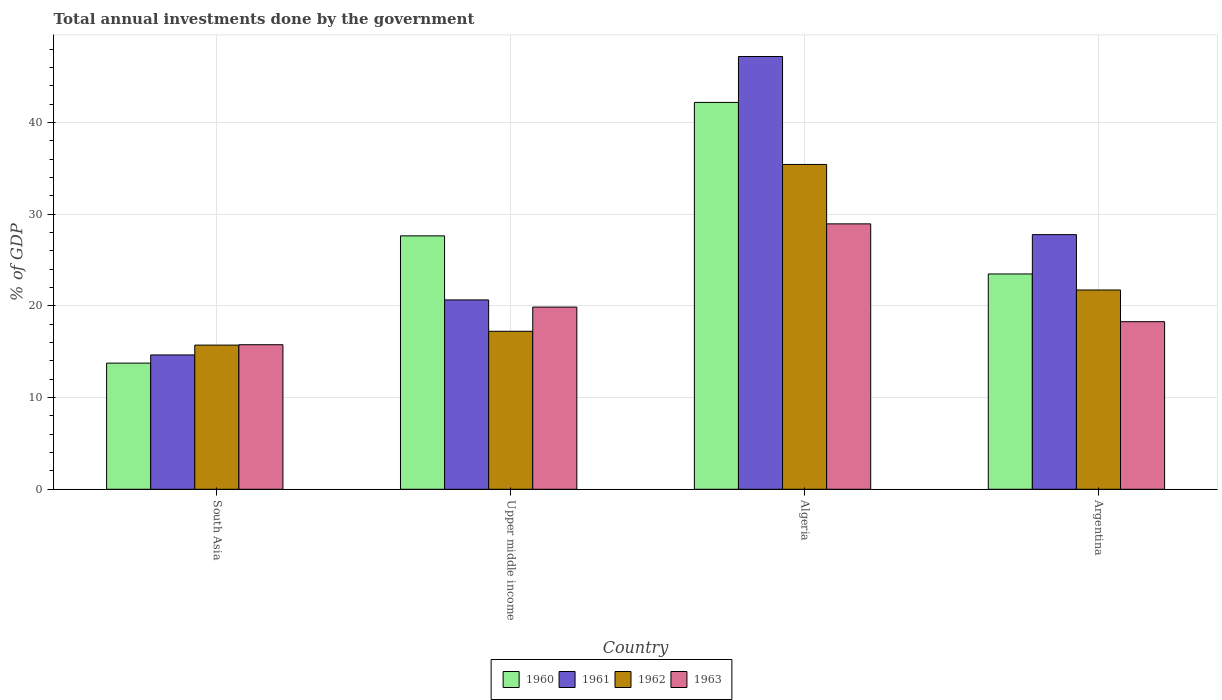Are the number of bars per tick equal to the number of legend labels?
Your answer should be very brief. Yes. Are the number of bars on each tick of the X-axis equal?
Keep it short and to the point. Yes. How many bars are there on the 1st tick from the right?
Offer a very short reply. 4. In how many cases, is the number of bars for a given country not equal to the number of legend labels?
Provide a succinct answer. 0. What is the total annual investments done by the government in 1963 in Upper middle income?
Keep it short and to the point. 19.87. Across all countries, what is the maximum total annual investments done by the government in 1960?
Give a very brief answer. 42.18. Across all countries, what is the minimum total annual investments done by the government in 1962?
Your response must be concise. 15.72. In which country was the total annual investments done by the government in 1961 maximum?
Your answer should be compact. Algeria. In which country was the total annual investments done by the government in 1961 minimum?
Provide a succinct answer. South Asia. What is the total total annual investments done by the government in 1962 in the graph?
Your answer should be compact. 90.1. What is the difference between the total annual investments done by the government in 1960 in South Asia and that in Upper middle income?
Your response must be concise. -13.88. What is the difference between the total annual investments done by the government in 1960 in South Asia and the total annual investments done by the government in 1963 in Argentina?
Provide a short and direct response. -4.52. What is the average total annual investments done by the government in 1961 per country?
Make the answer very short. 27.56. What is the difference between the total annual investments done by the government of/in 1963 and total annual investments done by the government of/in 1961 in South Asia?
Keep it short and to the point. 1.11. In how many countries, is the total annual investments done by the government in 1962 greater than 30 %?
Give a very brief answer. 1. What is the ratio of the total annual investments done by the government in 1963 in Algeria to that in Upper middle income?
Provide a short and direct response. 1.46. Is the difference between the total annual investments done by the government in 1963 in Algeria and South Asia greater than the difference between the total annual investments done by the government in 1961 in Algeria and South Asia?
Give a very brief answer. No. What is the difference between the highest and the second highest total annual investments done by the government in 1962?
Your response must be concise. -18.19. What is the difference between the highest and the lowest total annual investments done by the government in 1960?
Ensure brevity in your answer.  28.43. In how many countries, is the total annual investments done by the government in 1962 greater than the average total annual investments done by the government in 1962 taken over all countries?
Keep it short and to the point. 1. Is the sum of the total annual investments done by the government in 1963 in Argentina and Upper middle income greater than the maximum total annual investments done by the government in 1960 across all countries?
Offer a very short reply. No. How many bars are there?
Your answer should be very brief. 16. What is the difference between two consecutive major ticks on the Y-axis?
Provide a short and direct response. 10. Does the graph contain grids?
Your answer should be compact. Yes. Where does the legend appear in the graph?
Ensure brevity in your answer.  Bottom center. How are the legend labels stacked?
Ensure brevity in your answer.  Horizontal. What is the title of the graph?
Provide a succinct answer. Total annual investments done by the government. What is the label or title of the X-axis?
Ensure brevity in your answer.  Country. What is the label or title of the Y-axis?
Give a very brief answer. % of GDP. What is the % of GDP in 1960 in South Asia?
Your answer should be compact. 13.76. What is the % of GDP in 1961 in South Asia?
Offer a terse response. 14.65. What is the % of GDP of 1962 in South Asia?
Give a very brief answer. 15.72. What is the % of GDP of 1963 in South Asia?
Provide a succinct answer. 15.76. What is the % of GDP of 1960 in Upper middle income?
Ensure brevity in your answer.  27.63. What is the % of GDP in 1961 in Upper middle income?
Your answer should be very brief. 20.65. What is the % of GDP in 1962 in Upper middle income?
Your response must be concise. 17.23. What is the % of GDP in 1963 in Upper middle income?
Keep it short and to the point. 19.87. What is the % of GDP of 1960 in Algeria?
Provide a short and direct response. 42.18. What is the % of GDP of 1961 in Algeria?
Your response must be concise. 47.19. What is the % of GDP of 1962 in Algeria?
Offer a very short reply. 35.42. What is the % of GDP in 1963 in Algeria?
Offer a very short reply. 28.94. What is the % of GDP of 1960 in Argentina?
Your response must be concise. 23.48. What is the % of GDP in 1961 in Argentina?
Offer a very short reply. 27.77. What is the % of GDP in 1962 in Argentina?
Your response must be concise. 21.73. What is the % of GDP of 1963 in Argentina?
Provide a short and direct response. 18.27. Across all countries, what is the maximum % of GDP of 1960?
Provide a succinct answer. 42.18. Across all countries, what is the maximum % of GDP in 1961?
Offer a terse response. 47.19. Across all countries, what is the maximum % of GDP of 1962?
Offer a very short reply. 35.42. Across all countries, what is the maximum % of GDP in 1963?
Provide a short and direct response. 28.94. Across all countries, what is the minimum % of GDP in 1960?
Your answer should be compact. 13.76. Across all countries, what is the minimum % of GDP of 1961?
Ensure brevity in your answer.  14.65. Across all countries, what is the minimum % of GDP in 1962?
Your response must be concise. 15.72. Across all countries, what is the minimum % of GDP of 1963?
Keep it short and to the point. 15.76. What is the total % of GDP of 1960 in the graph?
Offer a terse response. 107.05. What is the total % of GDP in 1961 in the graph?
Provide a short and direct response. 110.25. What is the total % of GDP in 1962 in the graph?
Make the answer very short. 90.1. What is the total % of GDP of 1963 in the graph?
Your response must be concise. 82.84. What is the difference between the % of GDP in 1960 in South Asia and that in Upper middle income?
Keep it short and to the point. -13.88. What is the difference between the % of GDP of 1961 in South Asia and that in Upper middle income?
Keep it short and to the point. -6. What is the difference between the % of GDP of 1962 in South Asia and that in Upper middle income?
Offer a terse response. -1.51. What is the difference between the % of GDP of 1963 in South Asia and that in Upper middle income?
Offer a very short reply. -4.1. What is the difference between the % of GDP in 1960 in South Asia and that in Algeria?
Offer a terse response. -28.43. What is the difference between the % of GDP of 1961 in South Asia and that in Algeria?
Offer a terse response. -32.54. What is the difference between the % of GDP of 1962 in South Asia and that in Algeria?
Offer a terse response. -19.7. What is the difference between the % of GDP of 1963 in South Asia and that in Algeria?
Keep it short and to the point. -13.18. What is the difference between the % of GDP of 1960 in South Asia and that in Argentina?
Give a very brief answer. -9.72. What is the difference between the % of GDP of 1961 in South Asia and that in Argentina?
Provide a succinct answer. -13.12. What is the difference between the % of GDP in 1962 in South Asia and that in Argentina?
Provide a short and direct response. -6.01. What is the difference between the % of GDP in 1963 in South Asia and that in Argentina?
Ensure brevity in your answer.  -2.51. What is the difference between the % of GDP of 1960 in Upper middle income and that in Algeria?
Your answer should be compact. -14.55. What is the difference between the % of GDP of 1961 in Upper middle income and that in Algeria?
Give a very brief answer. -26.54. What is the difference between the % of GDP in 1962 in Upper middle income and that in Algeria?
Your answer should be very brief. -18.19. What is the difference between the % of GDP in 1963 in Upper middle income and that in Algeria?
Your response must be concise. -9.07. What is the difference between the % of GDP in 1960 in Upper middle income and that in Argentina?
Offer a very short reply. 4.15. What is the difference between the % of GDP of 1961 in Upper middle income and that in Argentina?
Offer a terse response. -7.12. What is the difference between the % of GDP of 1962 in Upper middle income and that in Argentina?
Your response must be concise. -4.5. What is the difference between the % of GDP of 1963 in Upper middle income and that in Argentina?
Provide a short and direct response. 1.59. What is the difference between the % of GDP in 1960 in Algeria and that in Argentina?
Provide a succinct answer. 18.71. What is the difference between the % of GDP of 1961 in Algeria and that in Argentina?
Make the answer very short. 19.42. What is the difference between the % of GDP of 1962 in Algeria and that in Argentina?
Your response must be concise. 13.69. What is the difference between the % of GDP in 1963 in Algeria and that in Argentina?
Keep it short and to the point. 10.67. What is the difference between the % of GDP in 1960 in South Asia and the % of GDP in 1961 in Upper middle income?
Offer a terse response. -6.89. What is the difference between the % of GDP of 1960 in South Asia and the % of GDP of 1962 in Upper middle income?
Make the answer very short. -3.47. What is the difference between the % of GDP of 1960 in South Asia and the % of GDP of 1963 in Upper middle income?
Keep it short and to the point. -6.11. What is the difference between the % of GDP in 1961 in South Asia and the % of GDP in 1962 in Upper middle income?
Offer a terse response. -2.58. What is the difference between the % of GDP in 1961 in South Asia and the % of GDP in 1963 in Upper middle income?
Make the answer very short. -5.22. What is the difference between the % of GDP in 1962 in South Asia and the % of GDP in 1963 in Upper middle income?
Your answer should be very brief. -4.15. What is the difference between the % of GDP in 1960 in South Asia and the % of GDP in 1961 in Algeria?
Give a very brief answer. -33.43. What is the difference between the % of GDP in 1960 in South Asia and the % of GDP in 1962 in Algeria?
Offer a terse response. -21.66. What is the difference between the % of GDP in 1960 in South Asia and the % of GDP in 1963 in Algeria?
Your response must be concise. -15.18. What is the difference between the % of GDP in 1961 in South Asia and the % of GDP in 1962 in Algeria?
Ensure brevity in your answer.  -20.77. What is the difference between the % of GDP in 1961 in South Asia and the % of GDP in 1963 in Algeria?
Your response must be concise. -14.29. What is the difference between the % of GDP of 1962 in South Asia and the % of GDP of 1963 in Algeria?
Keep it short and to the point. -13.22. What is the difference between the % of GDP of 1960 in South Asia and the % of GDP of 1961 in Argentina?
Your answer should be compact. -14.01. What is the difference between the % of GDP of 1960 in South Asia and the % of GDP of 1962 in Argentina?
Provide a short and direct response. -7.97. What is the difference between the % of GDP of 1960 in South Asia and the % of GDP of 1963 in Argentina?
Offer a very short reply. -4.52. What is the difference between the % of GDP in 1961 in South Asia and the % of GDP in 1962 in Argentina?
Provide a short and direct response. -7.08. What is the difference between the % of GDP in 1961 in South Asia and the % of GDP in 1963 in Argentina?
Give a very brief answer. -3.62. What is the difference between the % of GDP of 1962 in South Asia and the % of GDP of 1963 in Argentina?
Ensure brevity in your answer.  -2.55. What is the difference between the % of GDP of 1960 in Upper middle income and the % of GDP of 1961 in Algeria?
Make the answer very short. -19.56. What is the difference between the % of GDP of 1960 in Upper middle income and the % of GDP of 1962 in Algeria?
Offer a very short reply. -7.79. What is the difference between the % of GDP in 1960 in Upper middle income and the % of GDP in 1963 in Algeria?
Provide a short and direct response. -1.31. What is the difference between the % of GDP in 1961 in Upper middle income and the % of GDP in 1962 in Algeria?
Give a very brief answer. -14.77. What is the difference between the % of GDP of 1961 in Upper middle income and the % of GDP of 1963 in Algeria?
Provide a succinct answer. -8.29. What is the difference between the % of GDP in 1962 in Upper middle income and the % of GDP in 1963 in Algeria?
Offer a very short reply. -11.71. What is the difference between the % of GDP of 1960 in Upper middle income and the % of GDP of 1961 in Argentina?
Keep it short and to the point. -0.13. What is the difference between the % of GDP of 1960 in Upper middle income and the % of GDP of 1962 in Argentina?
Your answer should be very brief. 5.9. What is the difference between the % of GDP of 1960 in Upper middle income and the % of GDP of 1963 in Argentina?
Ensure brevity in your answer.  9.36. What is the difference between the % of GDP of 1961 in Upper middle income and the % of GDP of 1962 in Argentina?
Ensure brevity in your answer.  -1.08. What is the difference between the % of GDP in 1961 in Upper middle income and the % of GDP in 1963 in Argentina?
Give a very brief answer. 2.38. What is the difference between the % of GDP of 1962 in Upper middle income and the % of GDP of 1963 in Argentina?
Your answer should be very brief. -1.04. What is the difference between the % of GDP in 1960 in Algeria and the % of GDP in 1961 in Argentina?
Give a very brief answer. 14.42. What is the difference between the % of GDP of 1960 in Algeria and the % of GDP of 1962 in Argentina?
Provide a short and direct response. 20.45. What is the difference between the % of GDP of 1960 in Algeria and the % of GDP of 1963 in Argentina?
Provide a succinct answer. 23.91. What is the difference between the % of GDP of 1961 in Algeria and the % of GDP of 1962 in Argentina?
Provide a short and direct response. 25.46. What is the difference between the % of GDP in 1961 in Algeria and the % of GDP in 1963 in Argentina?
Provide a succinct answer. 28.92. What is the difference between the % of GDP in 1962 in Algeria and the % of GDP in 1963 in Argentina?
Ensure brevity in your answer.  17.15. What is the average % of GDP in 1960 per country?
Give a very brief answer. 26.76. What is the average % of GDP in 1961 per country?
Your response must be concise. 27.56. What is the average % of GDP of 1962 per country?
Give a very brief answer. 22.52. What is the average % of GDP in 1963 per country?
Your answer should be very brief. 20.71. What is the difference between the % of GDP in 1960 and % of GDP in 1961 in South Asia?
Offer a very short reply. -0.89. What is the difference between the % of GDP in 1960 and % of GDP in 1962 in South Asia?
Your answer should be very brief. -1.96. What is the difference between the % of GDP of 1960 and % of GDP of 1963 in South Asia?
Provide a short and direct response. -2.01. What is the difference between the % of GDP of 1961 and % of GDP of 1962 in South Asia?
Offer a very short reply. -1.07. What is the difference between the % of GDP of 1961 and % of GDP of 1963 in South Asia?
Your answer should be compact. -1.11. What is the difference between the % of GDP in 1962 and % of GDP in 1963 in South Asia?
Keep it short and to the point. -0.04. What is the difference between the % of GDP of 1960 and % of GDP of 1961 in Upper middle income?
Offer a very short reply. 6.98. What is the difference between the % of GDP in 1960 and % of GDP in 1962 in Upper middle income?
Provide a short and direct response. 10.4. What is the difference between the % of GDP of 1960 and % of GDP of 1963 in Upper middle income?
Offer a terse response. 7.77. What is the difference between the % of GDP in 1961 and % of GDP in 1962 in Upper middle income?
Ensure brevity in your answer.  3.42. What is the difference between the % of GDP in 1961 and % of GDP in 1963 in Upper middle income?
Your answer should be very brief. 0.78. What is the difference between the % of GDP in 1962 and % of GDP in 1963 in Upper middle income?
Give a very brief answer. -2.64. What is the difference between the % of GDP in 1960 and % of GDP in 1961 in Algeria?
Make the answer very short. -5. What is the difference between the % of GDP in 1960 and % of GDP in 1962 in Algeria?
Your answer should be very brief. 6.76. What is the difference between the % of GDP of 1960 and % of GDP of 1963 in Algeria?
Offer a terse response. 13.24. What is the difference between the % of GDP in 1961 and % of GDP in 1962 in Algeria?
Your answer should be very brief. 11.77. What is the difference between the % of GDP in 1961 and % of GDP in 1963 in Algeria?
Offer a very short reply. 18.25. What is the difference between the % of GDP in 1962 and % of GDP in 1963 in Algeria?
Ensure brevity in your answer.  6.48. What is the difference between the % of GDP of 1960 and % of GDP of 1961 in Argentina?
Provide a short and direct response. -4.29. What is the difference between the % of GDP in 1960 and % of GDP in 1962 in Argentina?
Offer a very short reply. 1.75. What is the difference between the % of GDP of 1960 and % of GDP of 1963 in Argentina?
Your answer should be very brief. 5.21. What is the difference between the % of GDP in 1961 and % of GDP in 1962 in Argentina?
Your answer should be compact. 6.04. What is the difference between the % of GDP of 1961 and % of GDP of 1963 in Argentina?
Ensure brevity in your answer.  9.49. What is the difference between the % of GDP in 1962 and % of GDP in 1963 in Argentina?
Your response must be concise. 3.46. What is the ratio of the % of GDP of 1960 in South Asia to that in Upper middle income?
Offer a terse response. 0.5. What is the ratio of the % of GDP in 1961 in South Asia to that in Upper middle income?
Your response must be concise. 0.71. What is the ratio of the % of GDP of 1962 in South Asia to that in Upper middle income?
Provide a short and direct response. 0.91. What is the ratio of the % of GDP in 1963 in South Asia to that in Upper middle income?
Provide a short and direct response. 0.79. What is the ratio of the % of GDP in 1960 in South Asia to that in Algeria?
Provide a succinct answer. 0.33. What is the ratio of the % of GDP of 1961 in South Asia to that in Algeria?
Your answer should be very brief. 0.31. What is the ratio of the % of GDP in 1962 in South Asia to that in Algeria?
Ensure brevity in your answer.  0.44. What is the ratio of the % of GDP in 1963 in South Asia to that in Algeria?
Your answer should be compact. 0.54. What is the ratio of the % of GDP in 1960 in South Asia to that in Argentina?
Your answer should be compact. 0.59. What is the ratio of the % of GDP of 1961 in South Asia to that in Argentina?
Provide a succinct answer. 0.53. What is the ratio of the % of GDP of 1962 in South Asia to that in Argentina?
Keep it short and to the point. 0.72. What is the ratio of the % of GDP in 1963 in South Asia to that in Argentina?
Your answer should be compact. 0.86. What is the ratio of the % of GDP in 1960 in Upper middle income to that in Algeria?
Provide a succinct answer. 0.66. What is the ratio of the % of GDP of 1961 in Upper middle income to that in Algeria?
Give a very brief answer. 0.44. What is the ratio of the % of GDP of 1962 in Upper middle income to that in Algeria?
Provide a short and direct response. 0.49. What is the ratio of the % of GDP of 1963 in Upper middle income to that in Algeria?
Offer a very short reply. 0.69. What is the ratio of the % of GDP of 1960 in Upper middle income to that in Argentina?
Provide a succinct answer. 1.18. What is the ratio of the % of GDP of 1961 in Upper middle income to that in Argentina?
Offer a very short reply. 0.74. What is the ratio of the % of GDP in 1962 in Upper middle income to that in Argentina?
Ensure brevity in your answer.  0.79. What is the ratio of the % of GDP of 1963 in Upper middle income to that in Argentina?
Your answer should be compact. 1.09. What is the ratio of the % of GDP in 1960 in Algeria to that in Argentina?
Your answer should be compact. 1.8. What is the ratio of the % of GDP in 1961 in Algeria to that in Argentina?
Give a very brief answer. 1.7. What is the ratio of the % of GDP in 1962 in Algeria to that in Argentina?
Give a very brief answer. 1.63. What is the ratio of the % of GDP of 1963 in Algeria to that in Argentina?
Your answer should be compact. 1.58. What is the difference between the highest and the second highest % of GDP in 1960?
Offer a very short reply. 14.55. What is the difference between the highest and the second highest % of GDP of 1961?
Provide a succinct answer. 19.42. What is the difference between the highest and the second highest % of GDP of 1962?
Your answer should be very brief. 13.69. What is the difference between the highest and the second highest % of GDP of 1963?
Provide a short and direct response. 9.07. What is the difference between the highest and the lowest % of GDP of 1960?
Give a very brief answer. 28.43. What is the difference between the highest and the lowest % of GDP of 1961?
Offer a very short reply. 32.54. What is the difference between the highest and the lowest % of GDP of 1962?
Make the answer very short. 19.7. What is the difference between the highest and the lowest % of GDP in 1963?
Keep it short and to the point. 13.18. 